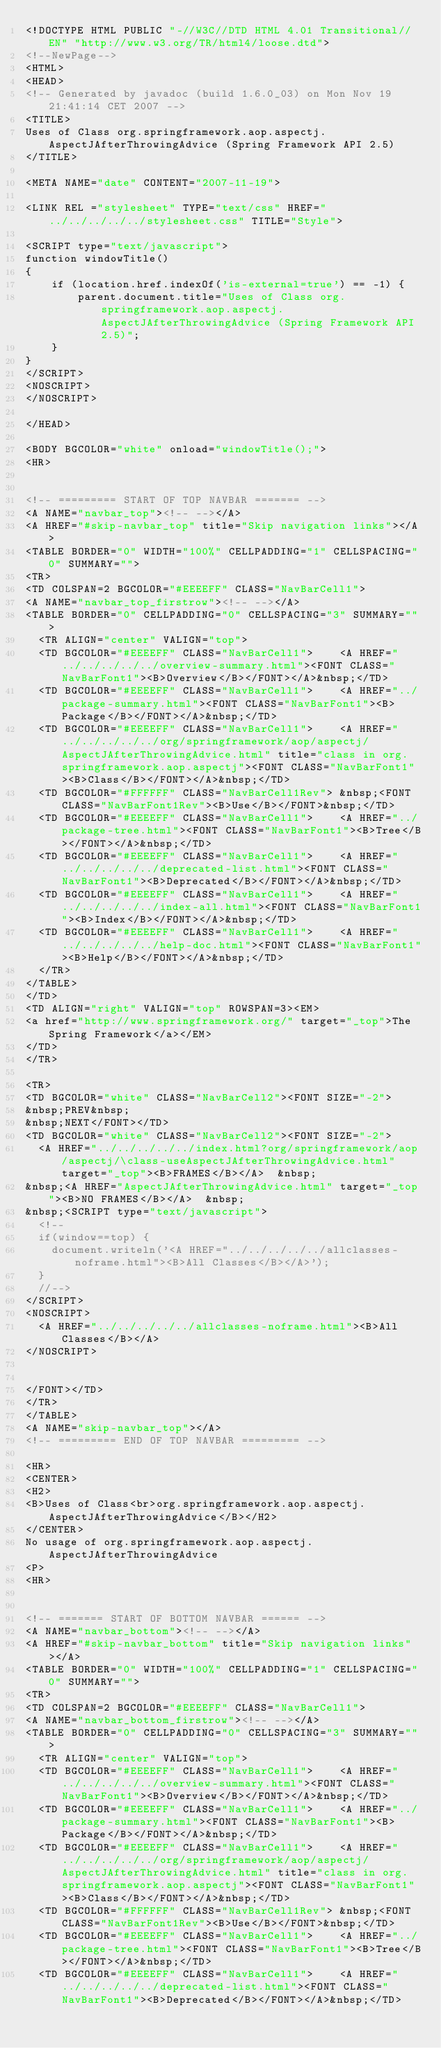<code> <loc_0><loc_0><loc_500><loc_500><_HTML_><!DOCTYPE HTML PUBLIC "-//W3C//DTD HTML 4.01 Transitional//EN" "http://www.w3.org/TR/html4/loose.dtd">
<!--NewPage-->
<HTML>
<HEAD>
<!-- Generated by javadoc (build 1.6.0_03) on Mon Nov 19 21:41:14 CET 2007 -->
<TITLE>
Uses of Class org.springframework.aop.aspectj.AspectJAfterThrowingAdvice (Spring Framework API 2.5)
</TITLE>

<META NAME="date" CONTENT="2007-11-19">

<LINK REL ="stylesheet" TYPE="text/css" HREF="../../../../../stylesheet.css" TITLE="Style">

<SCRIPT type="text/javascript">
function windowTitle()
{
    if (location.href.indexOf('is-external=true') == -1) {
        parent.document.title="Uses of Class org.springframework.aop.aspectj.AspectJAfterThrowingAdvice (Spring Framework API 2.5)";
    }
}
</SCRIPT>
<NOSCRIPT>
</NOSCRIPT>

</HEAD>

<BODY BGCOLOR="white" onload="windowTitle();">
<HR>


<!-- ========= START OF TOP NAVBAR ======= -->
<A NAME="navbar_top"><!-- --></A>
<A HREF="#skip-navbar_top" title="Skip navigation links"></A>
<TABLE BORDER="0" WIDTH="100%" CELLPADDING="1" CELLSPACING="0" SUMMARY="">
<TR>
<TD COLSPAN=2 BGCOLOR="#EEEEFF" CLASS="NavBarCell1">
<A NAME="navbar_top_firstrow"><!-- --></A>
<TABLE BORDER="0" CELLPADDING="0" CELLSPACING="3" SUMMARY="">
  <TR ALIGN="center" VALIGN="top">
  <TD BGCOLOR="#EEEEFF" CLASS="NavBarCell1">    <A HREF="../../../../../overview-summary.html"><FONT CLASS="NavBarFont1"><B>Overview</B></FONT></A>&nbsp;</TD>
  <TD BGCOLOR="#EEEEFF" CLASS="NavBarCell1">    <A HREF="../package-summary.html"><FONT CLASS="NavBarFont1"><B>Package</B></FONT></A>&nbsp;</TD>
  <TD BGCOLOR="#EEEEFF" CLASS="NavBarCell1">    <A HREF="../../../../../org/springframework/aop/aspectj/AspectJAfterThrowingAdvice.html" title="class in org.springframework.aop.aspectj"><FONT CLASS="NavBarFont1"><B>Class</B></FONT></A>&nbsp;</TD>
  <TD BGCOLOR="#FFFFFF" CLASS="NavBarCell1Rev"> &nbsp;<FONT CLASS="NavBarFont1Rev"><B>Use</B></FONT>&nbsp;</TD>
  <TD BGCOLOR="#EEEEFF" CLASS="NavBarCell1">    <A HREF="../package-tree.html"><FONT CLASS="NavBarFont1"><B>Tree</B></FONT></A>&nbsp;</TD>
  <TD BGCOLOR="#EEEEFF" CLASS="NavBarCell1">    <A HREF="../../../../../deprecated-list.html"><FONT CLASS="NavBarFont1"><B>Deprecated</B></FONT></A>&nbsp;</TD>
  <TD BGCOLOR="#EEEEFF" CLASS="NavBarCell1">    <A HREF="../../../../../index-all.html"><FONT CLASS="NavBarFont1"><B>Index</B></FONT></A>&nbsp;</TD>
  <TD BGCOLOR="#EEEEFF" CLASS="NavBarCell1">    <A HREF="../../../../../help-doc.html"><FONT CLASS="NavBarFont1"><B>Help</B></FONT></A>&nbsp;</TD>
  </TR>
</TABLE>
</TD>
<TD ALIGN="right" VALIGN="top" ROWSPAN=3><EM>
<a href="http://www.springframework.org/" target="_top">The Spring Framework</a></EM>
</TD>
</TR>

<TR>
<TD BGCOLOR="white" CLASS="NavBarCell2"><FONT SIZE="-2">
&nbsp;PREV&nbsp;
&nbsp;NEXT</FONT></TD>
<TD BGCOLOR="white" CLASS="NavBarCell2"><FONT SIZE="-2">
  <A HREF="../../../../../index.html?org/springframework/aop/aspectj/\class-useAspectJAfterThrowingAdvice.html" target="_top"><B>FRAMES</B></A>  &nbsp;
&nbsp;<A HREF="AspectJAfterThrowingAdvice.html" target="_top"><B>NO FRAMES</B></A>  &nbsp;
&nbsp;<SCRIPT type="text/javascript">
  <!--
  if(window==top) {
    document.writeln('<A HREF="../../../../../allclasses-noframe.html"><B>All Classes</B></A>');
  }
  //-->
</SCRIPT>
<NOSCRIPT>
  <A HREF="../../../../../allclasses-noframe.html"><B>All Classes</B></A>
</NOSCRIPT>


</FONT></TD>
</TR>
</TABLE>
<A NAME="skip-navbar_top"></A>
<!-- ========= END OF TOP NAVBAR ========= -->

<HR>
<CENTER>
<H2>
<B>Uses of Class<br>org.springframework.aop.aspectj.AspectJAfterThrowingAdvice</B></H2>
</CENTER>
No usage of org.springframework.aop.aspectj.AspectJAfterThrowingAdvice
<P>
<HR>


<!-- ======= START OF BOTTOM NAVBAR ====== -->
<A NAME="navbar_bottom"><!-- --></A>
<A HREF="#skip-navbar_bottom" title="Skip navigation links"></A>
<TABLE BORDER="0" WIDTH="100%" CELLPADDING="1" CELLSPACING="0" SUMMARY="">
<TR>
<TD COLSPAN=2 BGCOLOR="#EEEEFF" CLASS="NavBarCell1">
<A NAME="navbar_bottom_firstrow"><!-- --></A>
<TABLE BORDER="0" CELLPADDING="0" CELLSPACING="3" SUMMARY="">
  <TR ALIGN="center" VALIGN="top">
  <TD BGCOLOR="#EEEEFF" CLASS="NavBarCell1">    <A HREF="../../../../../overview-summary.html"><FONT CLASS="NavBarFont1"><B>Overview</B></FONT></A>&nbsp;</TD>
  <TD BGCOLOR="#EEEEFF" CLASS="NavBarCell1">    <A HREF="../package-summary.html"><FONT CLASS="NavBarFont1"><B>Package</B></FONT></A>&nbsp;</TD>
  <TD BGCOLOR="#EEEEFF" CLASS="NavBarCell1">    <A HREF="../../../../../org/springframework/aop/aspectj/AspectJAfterThrowingAdvice.html" title="class in org.springframework.aop.aspectj"><FONT CLASS="NavBarFont1"><B>Class</B></FONT></A>&nbsp;</TD>
  <TD BGCOLOR="#FFFFFF" CLASS="NavBarCell1Rev"> &nbsp;<FONT CLASS="NavBarFont1Rev"><B>Use</B></FONT>&nbsp;</TD>
  <TD BGCOLOR="#EEEEFF" CLASS="NavBarCell1">    <A HREF="../package-tree.html"><FONT CLASS="NavBarFont1"><B>Tree</B></FONT></A>&nbsp;</TD>
  <TD BGCOLOR="#EEEEFF" CLASS="NavBarCell1">    <A HREF="../../../../../deprecated-list.html"><FONT CLASS="NavBarFont1"><B>Deprecated</B></FONT></A>&nbsp;</TD></code> 